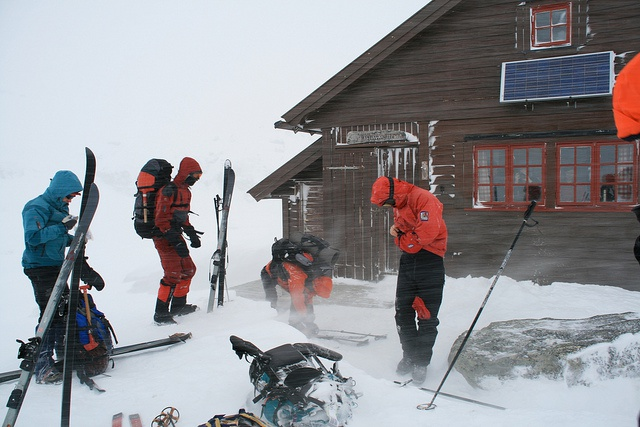Describe the objects in this image and their specific colors. I can see people in lightgray, black, brown, gray, and red tones, people in lightgray, black, maroon, and brown tones, people in lightgray, blue, teal, and black tones, backpack in lightgray, black, gray, and darkgray tones, and people in lightgray, darkgray, brown, gray, and black tones in this image. 